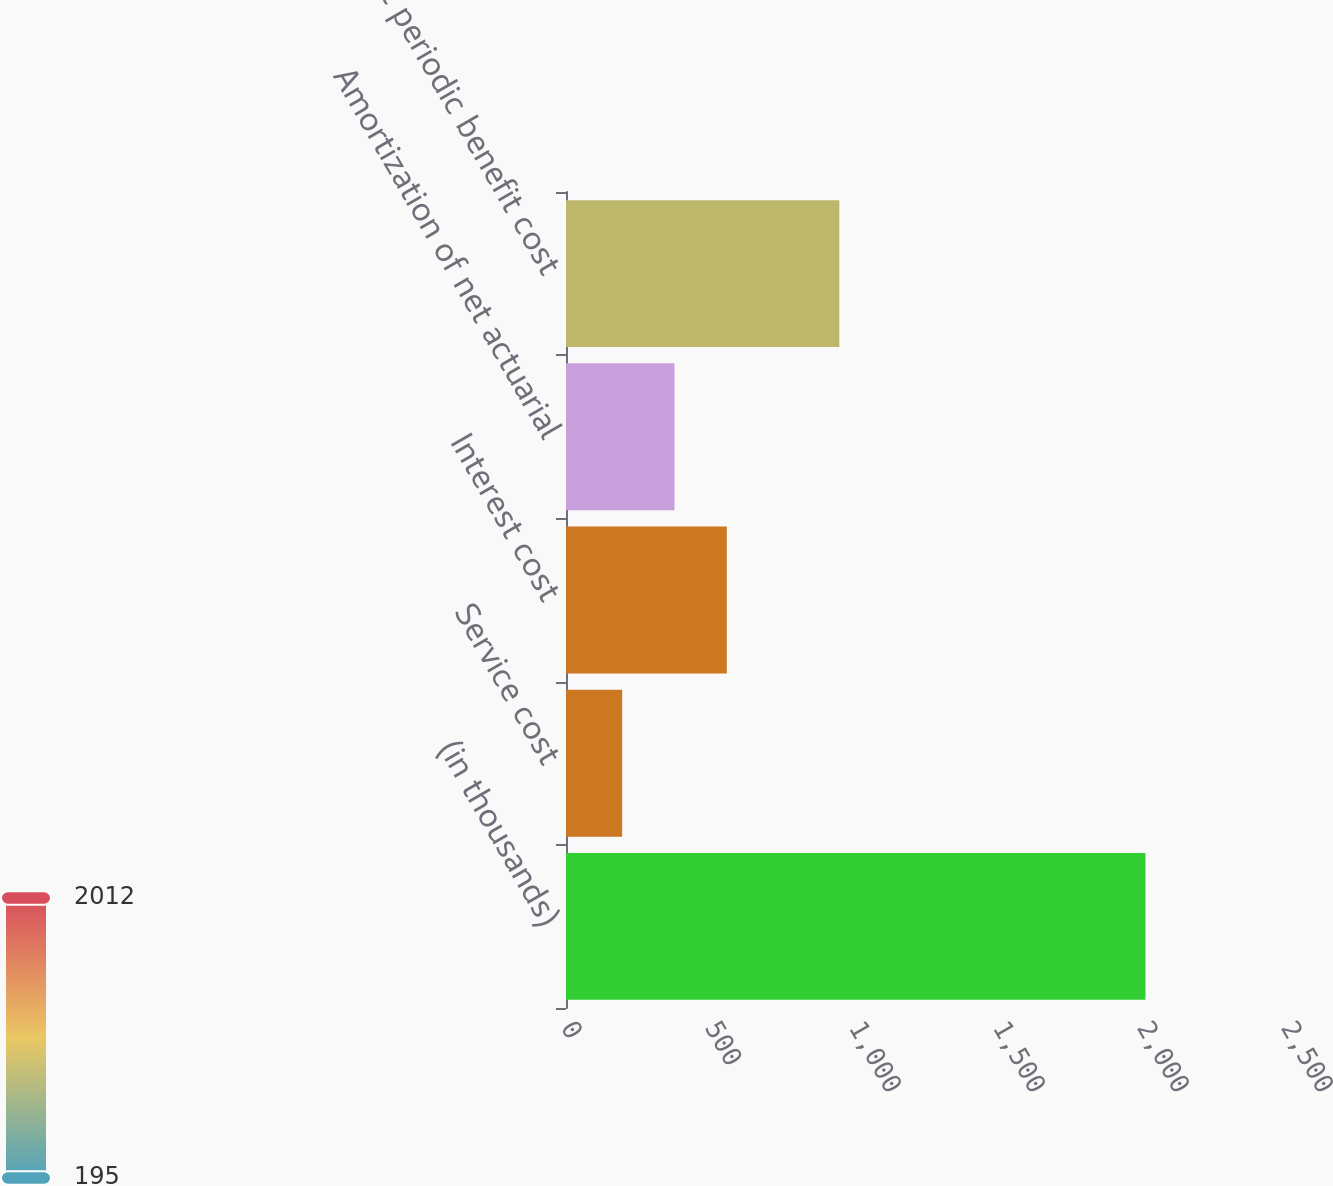<chart> <loc_0><loc_0><loc_500><loc_500><bar_chart><fcel>(in thousands)<fcel>Service cost<fcel>Interest cost<fcel>Amortization of net actuarial<fcel>Net periodic benefit cost<nl><fcel>2012<fcel>195<fcel>558.4<fcel>376.7<fcel>949<nl></chart> 